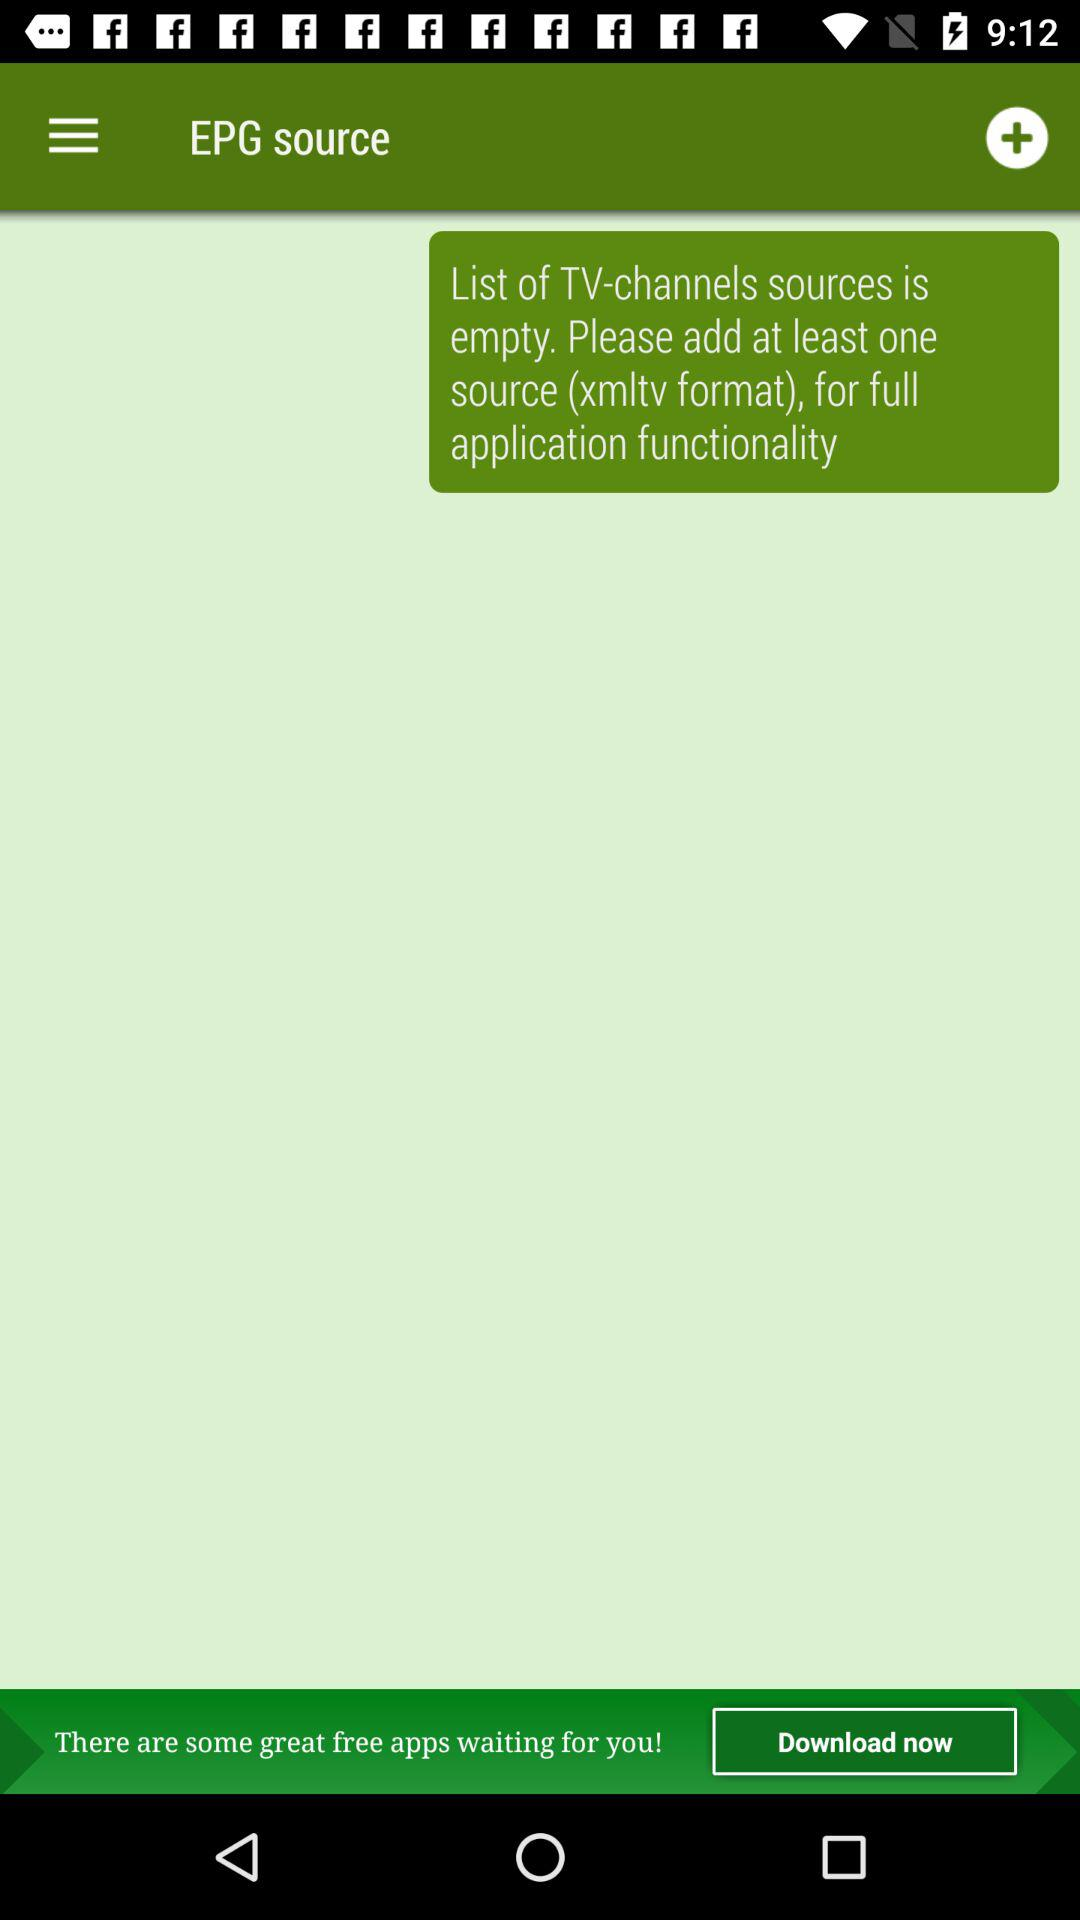What is the application name? The application name is "EPG". 